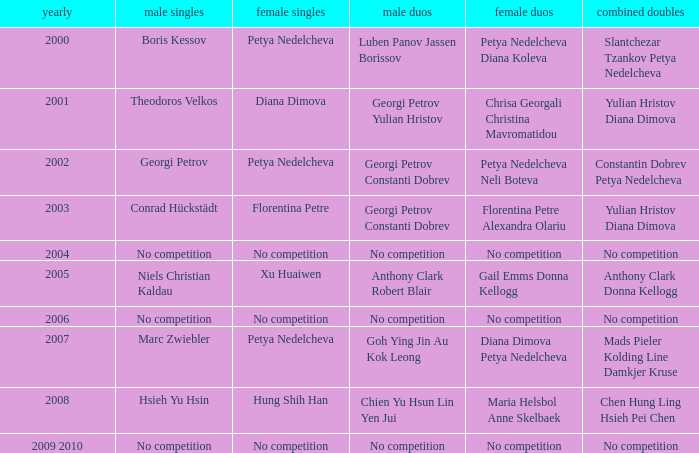In what year was there no competition for women? 2004, 2006, 2009 2010. 